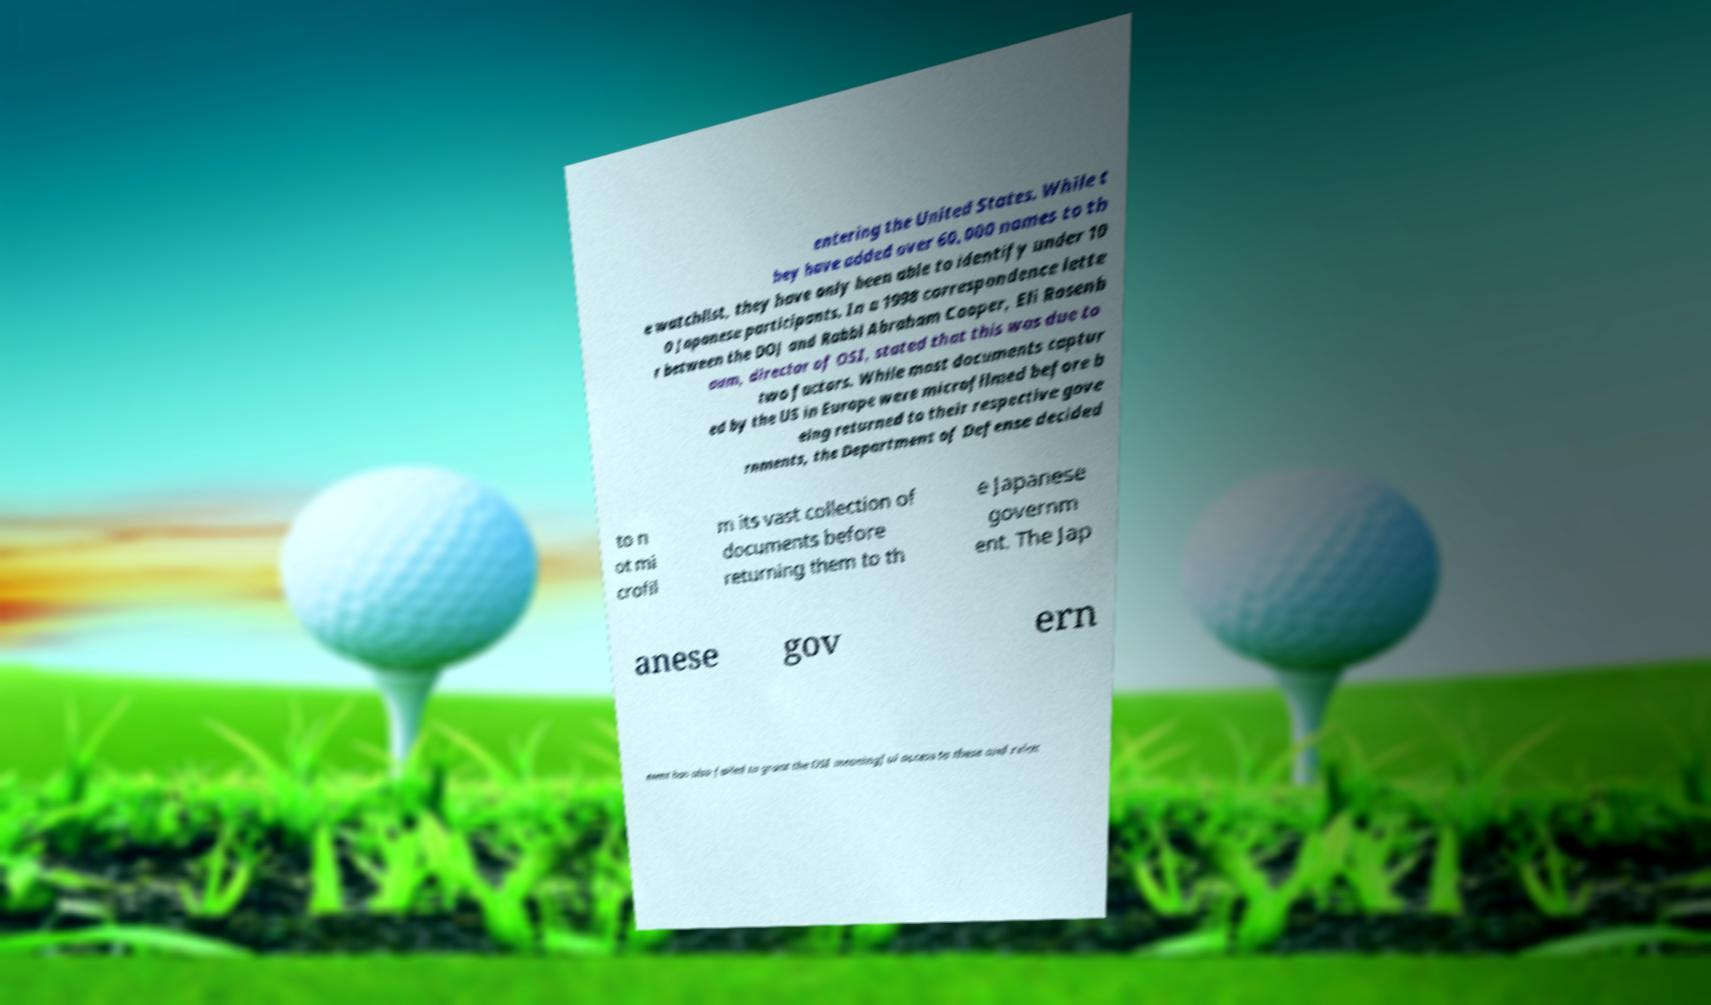Please read and relay the text visible in this image. What does it say? entering the United States. While t hey have added over 60,000 names to th e watchlist, they have only been able to identify under 10 0 Japanese participants. In a 1998 correspondence lette r between the DOJ and Rabbi Abraham Cooper, Eli Rosenb aum, director of OSI, stated that this was due to two factors. While most documents captur ed by the US in Europe were microfilmed before b eing returned to their respective gove rnments, the Department of Defense decided to n ot mi crofil m its vast collection of documents before returning them to th e Japanese governm ent. The Jap anese gov ern ment has also failed to grant the OSI meaningful access to these and relat 